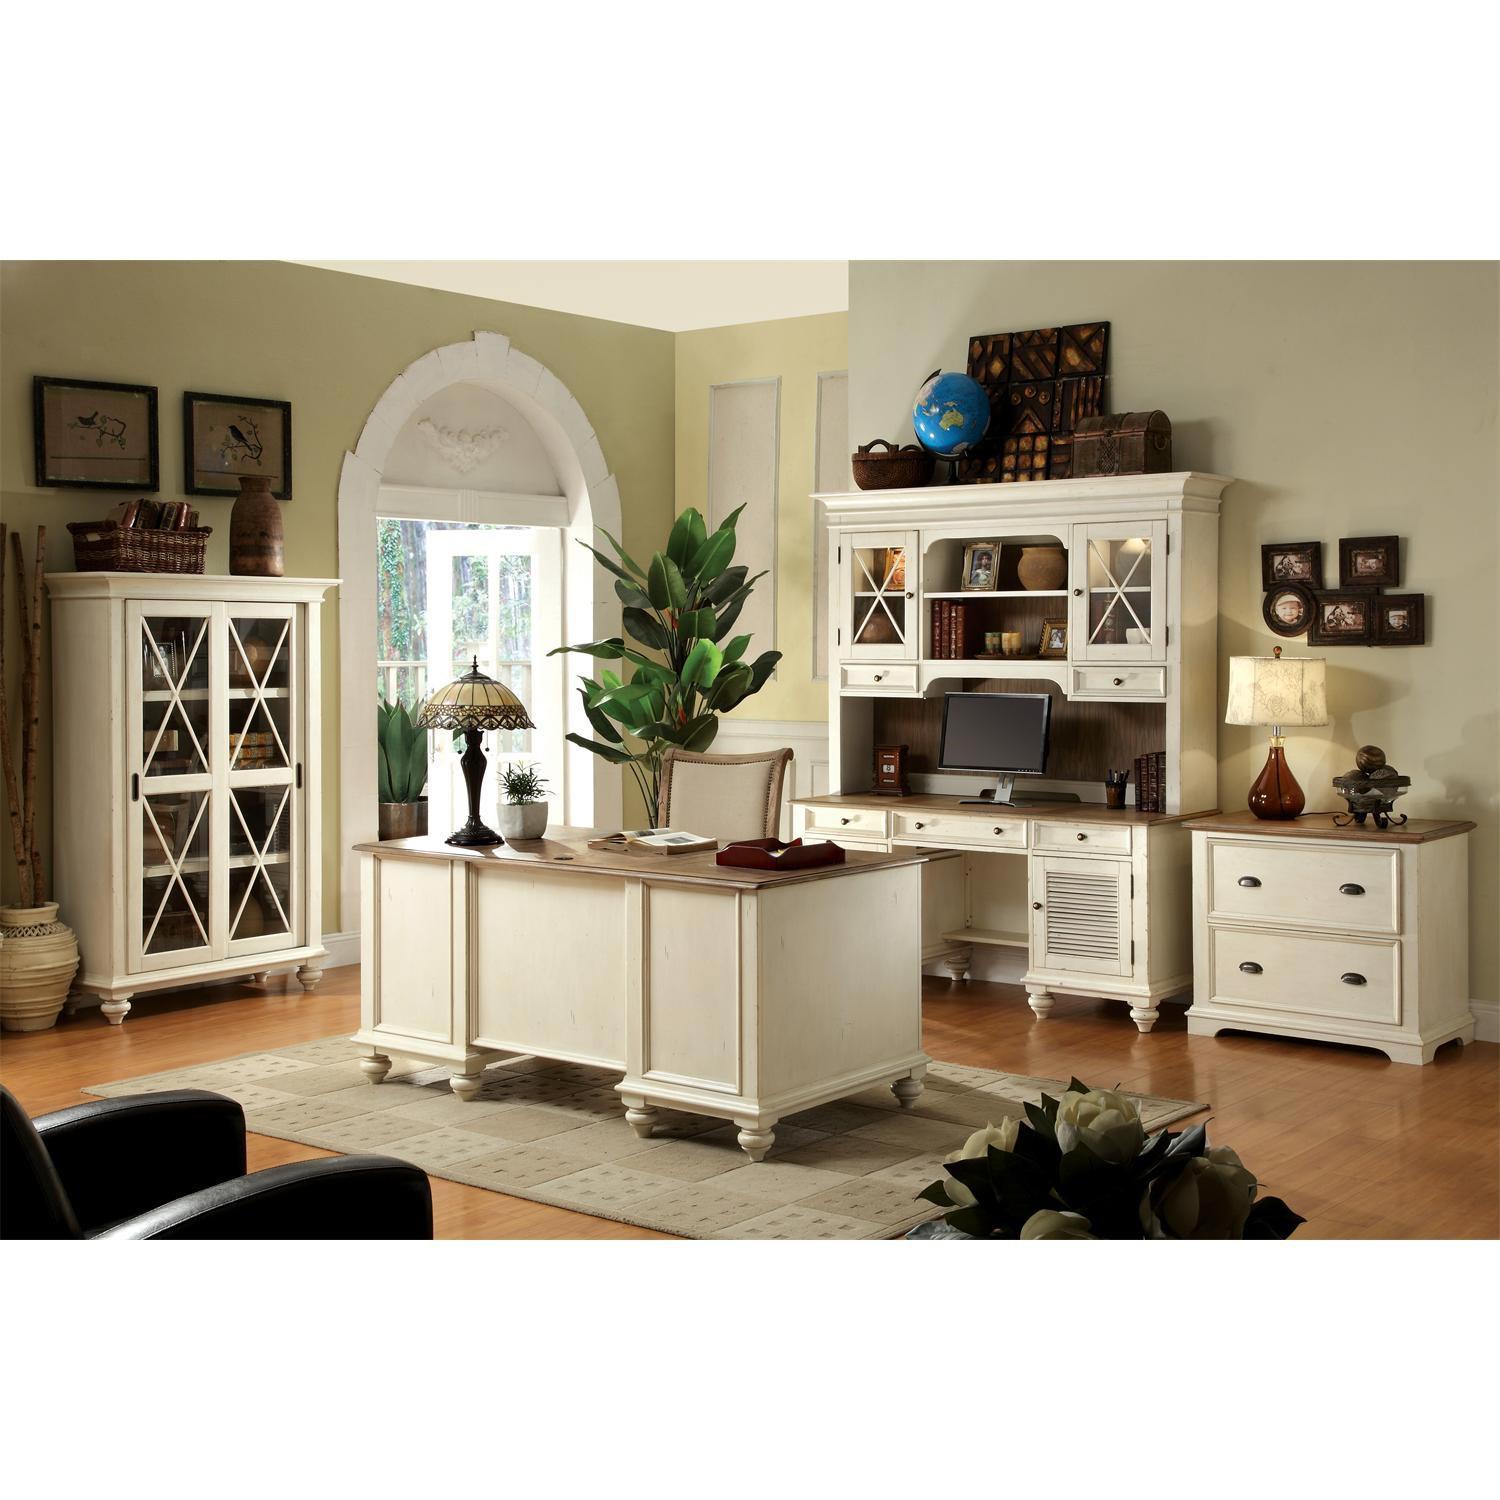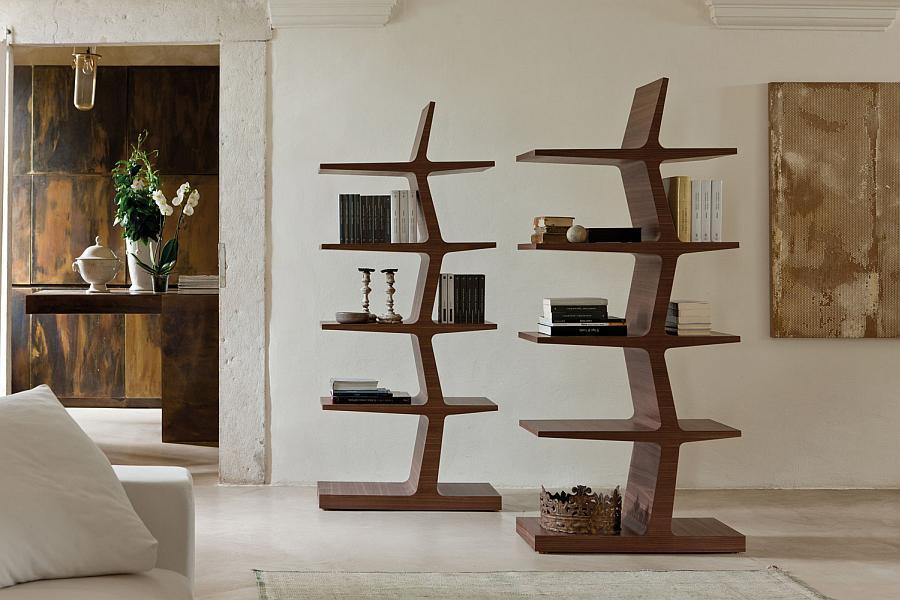The first image is the image on the left, the second image is the image on the right. Analyze the images presented: Is the assertion "One image features a backless, sideless style of shelf storage in brown wood, and the other image features more traditional styling with glass-fronted enclosed white cabinets." valid? Answer yes or no. Yes. The first image is the image on the left, the second image is the image on the right. Analyze the images presented: Is the assertion "The shelves in the image on the left have no doors." valid? Answer yes or no. No. 